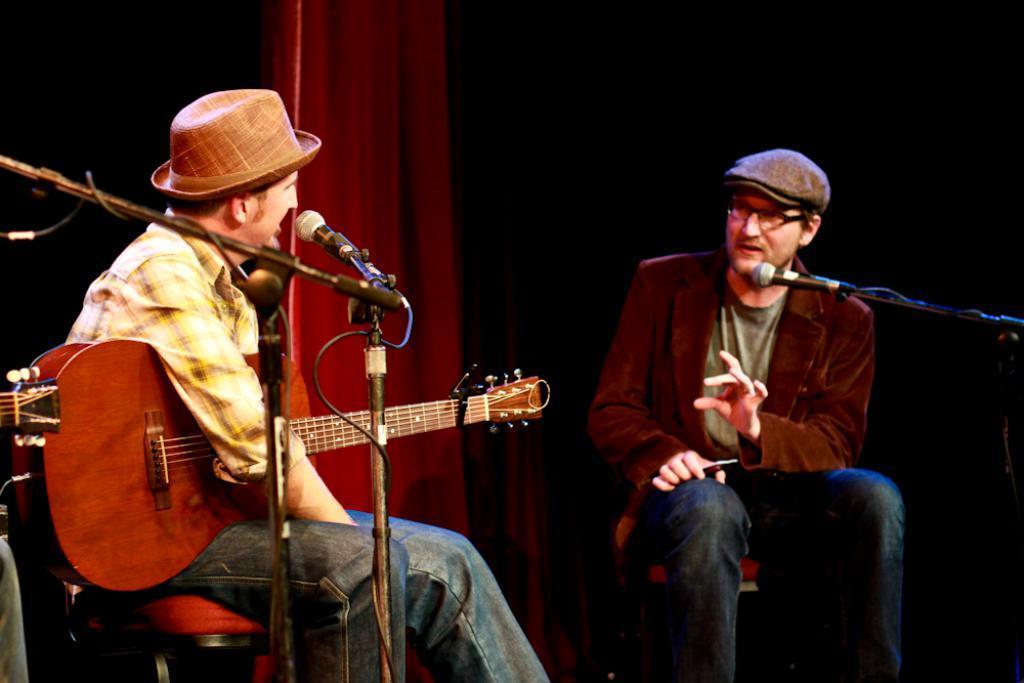Describe this image in one or two sentences. Background is dark and we can see a red colour curtain. We can see a red colour curtain. We can see two men wearing caps sitting on chairs in front of a mike. This man is holding a guitar in his hands. This man is holding a mobile in his hands and he is talking. 